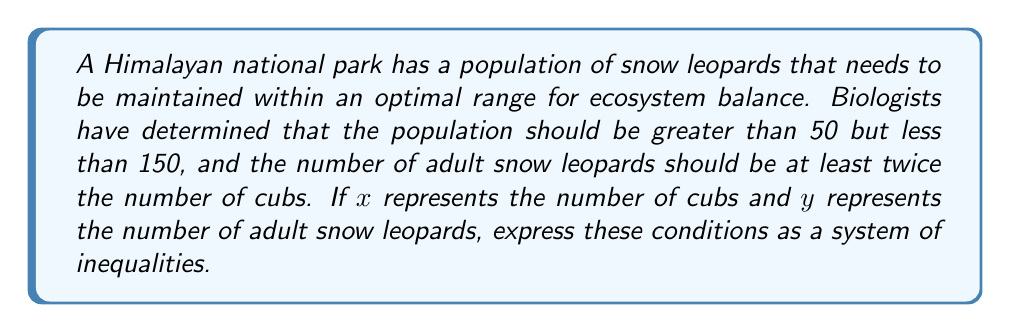Could you help me with this problem? Let's break this down step-by-step:

1) The total population should be greater than 50:
   $x + y > 50$

2) The total population should be less than 150:
   $x + y < 150$

3) The number of adult snow leopards should be at least twice the number of cubs:
   $y \geq 2x$

4) Since we're dealing with a population, both x and y must be non-negative:
   $x \geq 0$
   $y \geq 0$

Combining all these inequalities, we get the system:

$$\begin{cases}
x + y > 50 \\
x + y < 150 \\
y \geq 2x \\
x \geq 0 \\
y \geq 0
\end{cases}$$

This system of inequalities defines the optimal range for the snow leopard population in the national park, ensuring a sustainable ecosystem.
Answer: $$\begin{cases}
x + y > 50 \\
x + y < 150 \\
y \geq 2x \\
x \geq 0 \\
y \geq 0
\end{cases}$$ 